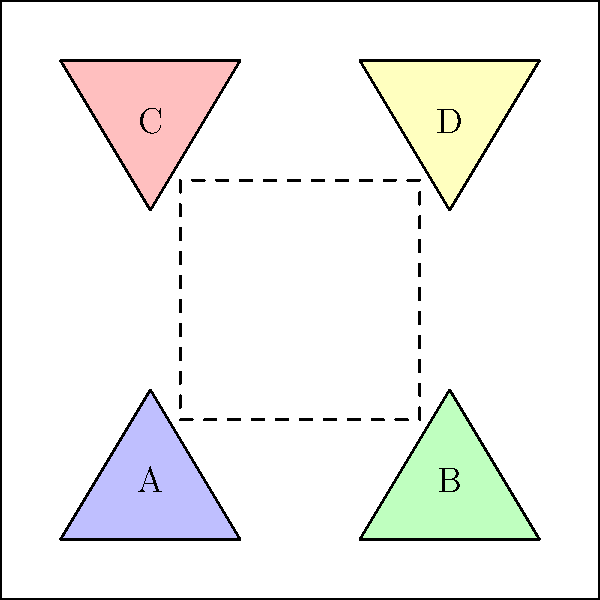In the mysterious labyrinth before you, a hidden passage is concealed behind four congruent triangular panels. To unlock the secret door, you must determine which pair of triangles, when combined, forms a rectangle. Which two letters represent the correct combination? To solve this brain teaser, we need to carefully examine the properties of the four triangular panels and determine which pair can form a rectangle when combined. Let's approach this step-by-step:

1. First, note that all four triangles are congruent, as stated in the question. This means they have the same size and shape.

2. To form a rectangle, we need to combine two triangles that, when placed together, create four right angles and have opposite sides that are parallel and equal in length.

3. Let's analyze the orientation of each triangle:
   - Triangle A: Base on bottom, apex pointing up
   - Triangle B: Base on bottom, apex pointing up
   - Triangle C: Base on top, apex pointing down
   - Triangle D: Base on top, apex pointing down

4. To create a rectangle, we need to combine triangles with opposite orientations. This immediately rules out combinations AB and CD.

5. The remaining possibilities are AC and BD. Let's consider these:
   - Combination AC: When placed together, these triangles would form a parallelogram, but not a rectangle, as the angles would not be right angles.
   - Combination BD: These triangles have opposite orientations and, when placed together, their hypotenuses would form the diagonal of a rectangle.

6. Therefore, the correct combination is B and D. When these triangles are placed together, they form a rectangle with the following properties:
   - The bases of the triangles form the top and bottom sides of the rectangle.
   - The vertical sides of the triangles form the left and right sides of the rectangle.
   - The hypotenuses of the triangles meet to form the diagonal of the rectangle.

Thus, combining triangles B and D will unlock the hidden passage in the labyrinth.
Answer: BD 